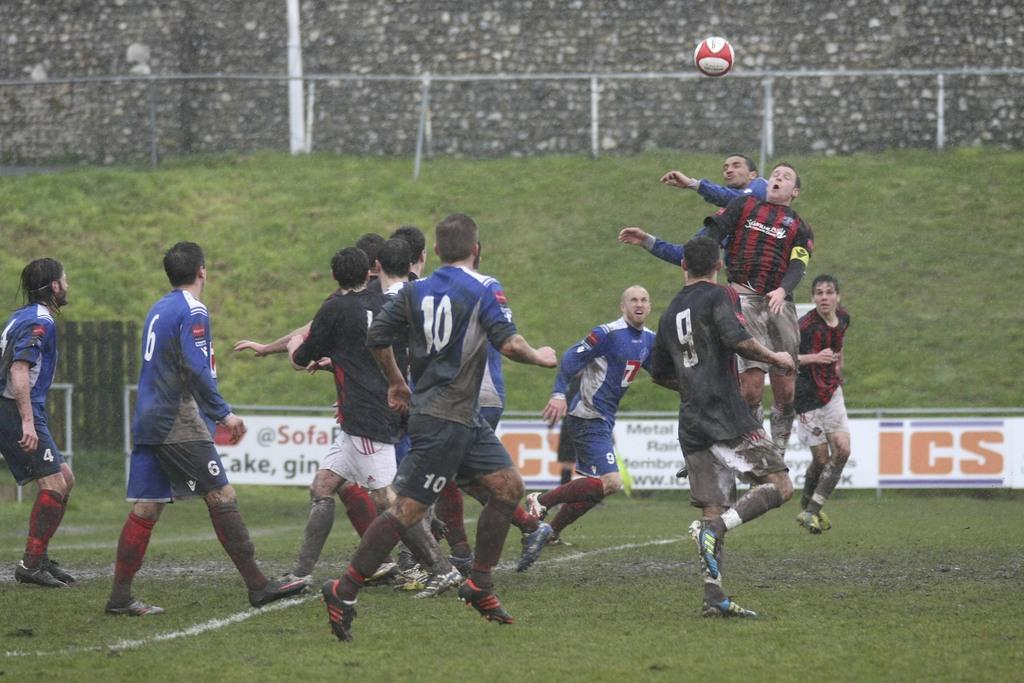<image>
Describe the image concisely. ICS, cake, and gin wrote on a white poster behind soccer players 